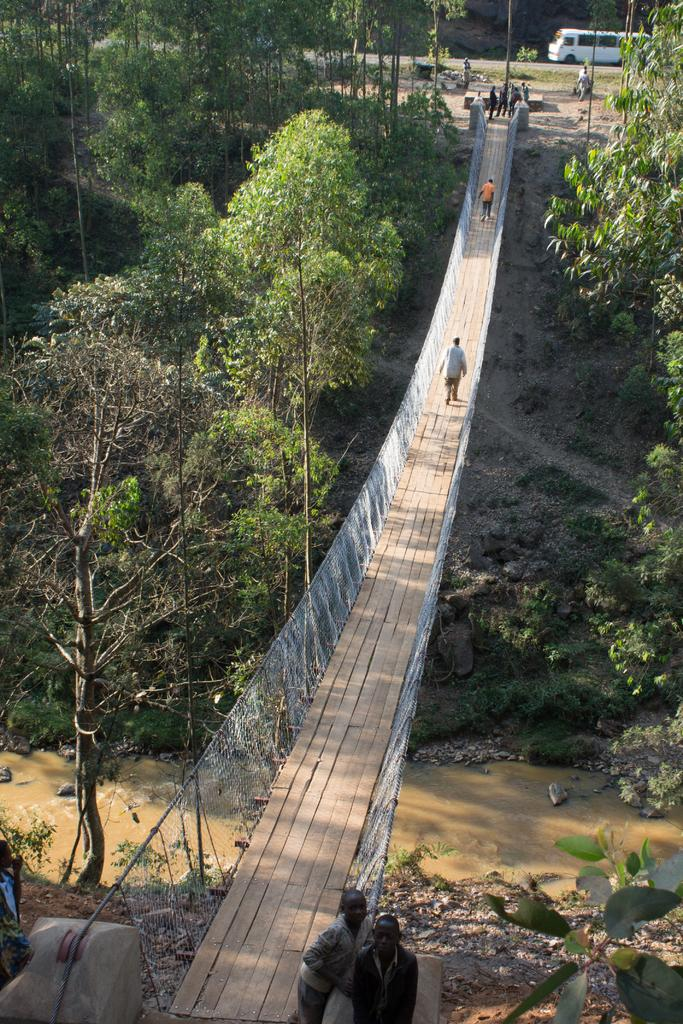What structure is present in the image that allows people to cross a river? There is a bridge in the image that allows people to cross a river. What is the bridge positioned over? The bridge is positioned across a river. Can you describe the surroundings of the bridge? There are people on either side of the bridge, and there are trees around the bridge. What can be seen in the background of the image? There is a vehicle visible in the background. How many gold coins can be seen in the river under the bridge? There are no gold coins visible in the river under the bridge in the image. Can you describe the girl standing on the bridge? There is no girl present on the bridge in the image. 